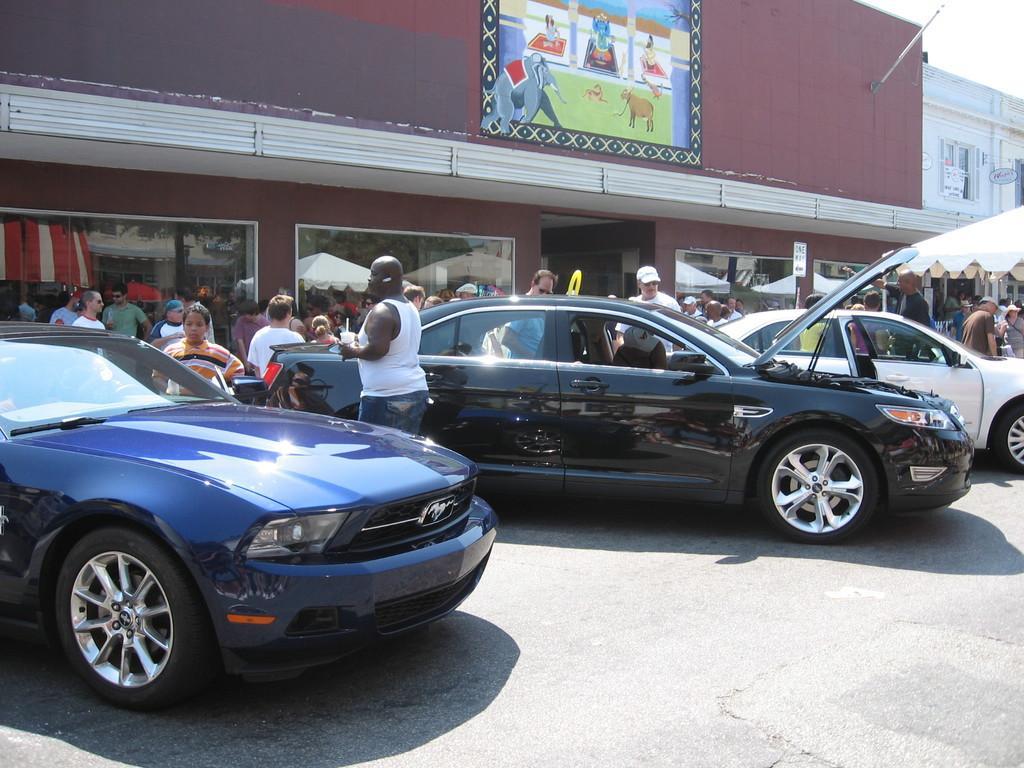Please provide a concise description of this image. In this image i can see few vehicles parked and number of people standing behind them. In the background i can see a building, sky and a board. 